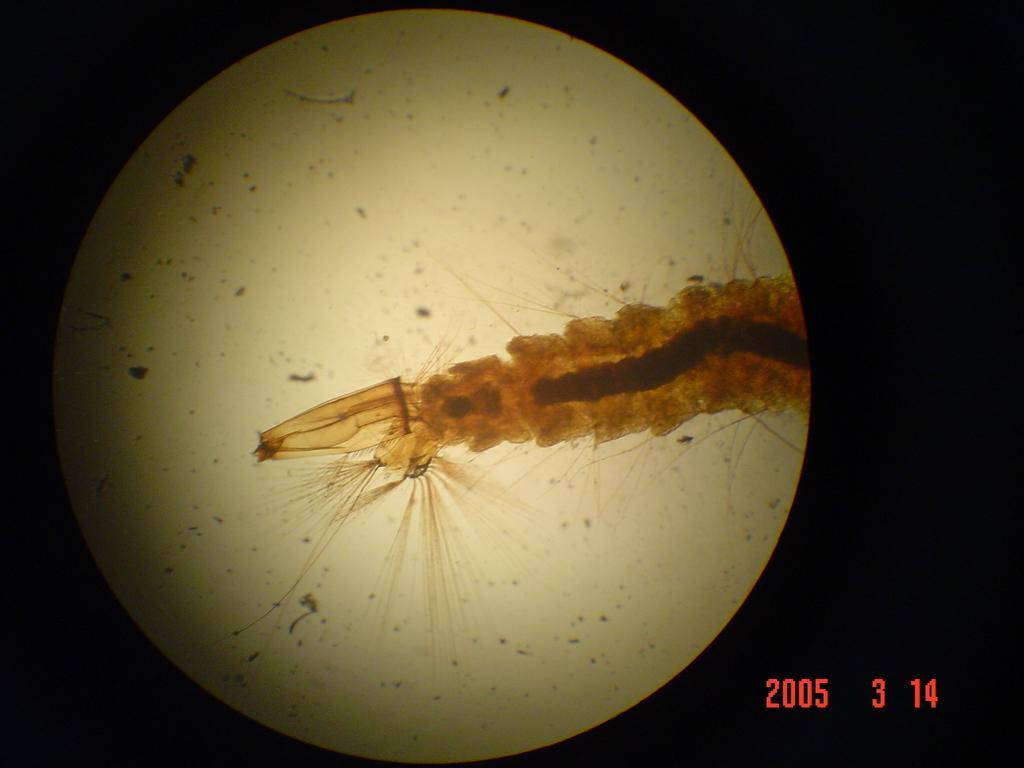Could you give a brief overview of what you see in this image? In this picture it looks like a graphical image of the moon, there is a dark background, we can see some numbers at the right bottom. 